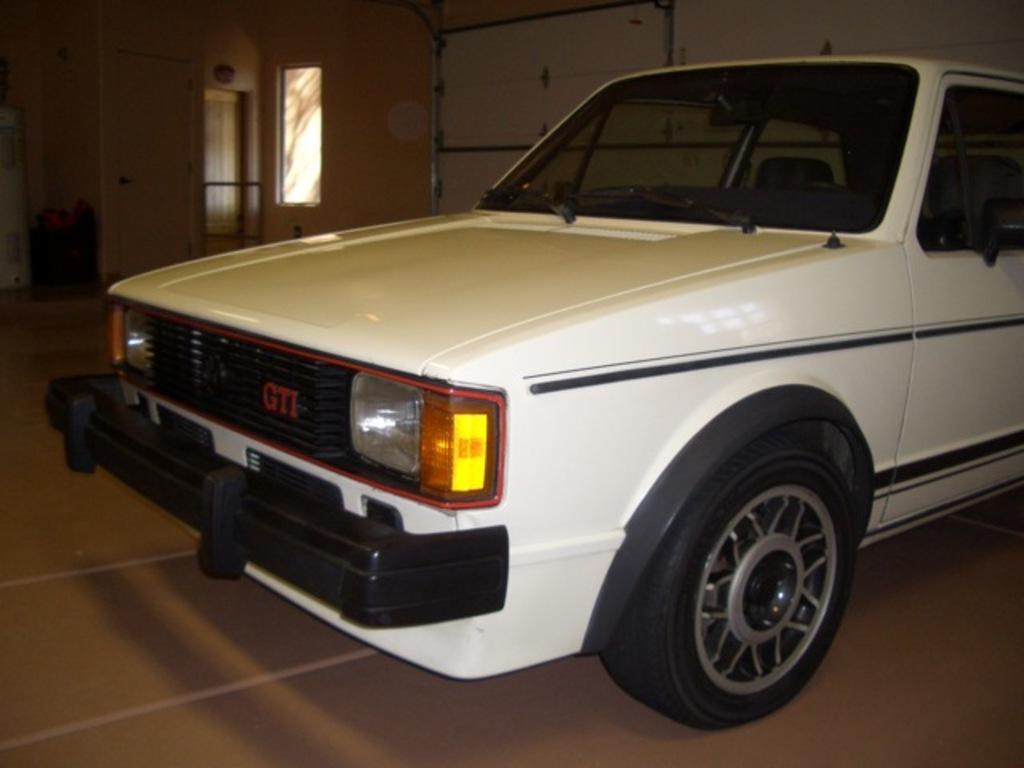Can you describe this image briefly? In this image, we can see a vehicle beside the wall. There is a window and door in the top left of the image. 